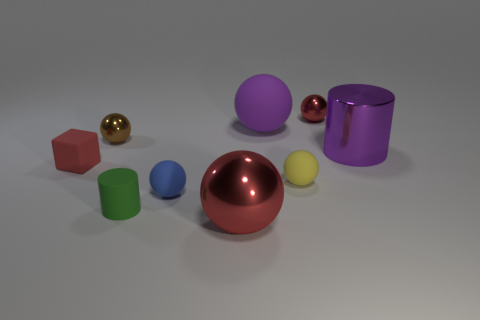What is the small red thing that is left of the metallic sphere that is behind the purple matte thing made of?
Your answer should be very brief. Rubber. What number of other objects are the same material as the brown sphere?
Provide a short and direct response. 3. There is a green cylinder that is the same size as the blue thing; what is it made of?
Offer a very short reply. Rubber. Are there more yellow matte spheres to the left of the yellow rubber ball than purple matte things left of the green cylinder?
Keep it short and to the point. No. Are there any big purple matte things that have the same shape as the green object?
Offer a terse response. No. The blue object that is the same size as the red matte thing is what shape?
Offer a terse response. Sphere. What shape is the large shiny object that is right of the small red sphere?
Give a very brief answer. Cylinder. Is the number of blue objects that are right of the cube less than the number of big metallic spheres to the left of the blue rubber object?
Your response must be concise. No. Do the metallic cylinder and the object in front of the green thing have the same size?
Your response must be concise. Yes. What number of blue matte objects have the same size as the purple ball?
Keep it short and to the point. 0. 